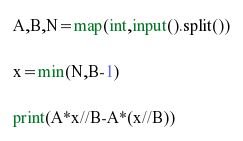<code> <loc_0><loc_0><loc_500><loc_500><_Python_>A,B,N=map(int,input().split())

x=min(N,B-1)

print(A*x//B-A*(x//B))</code> 